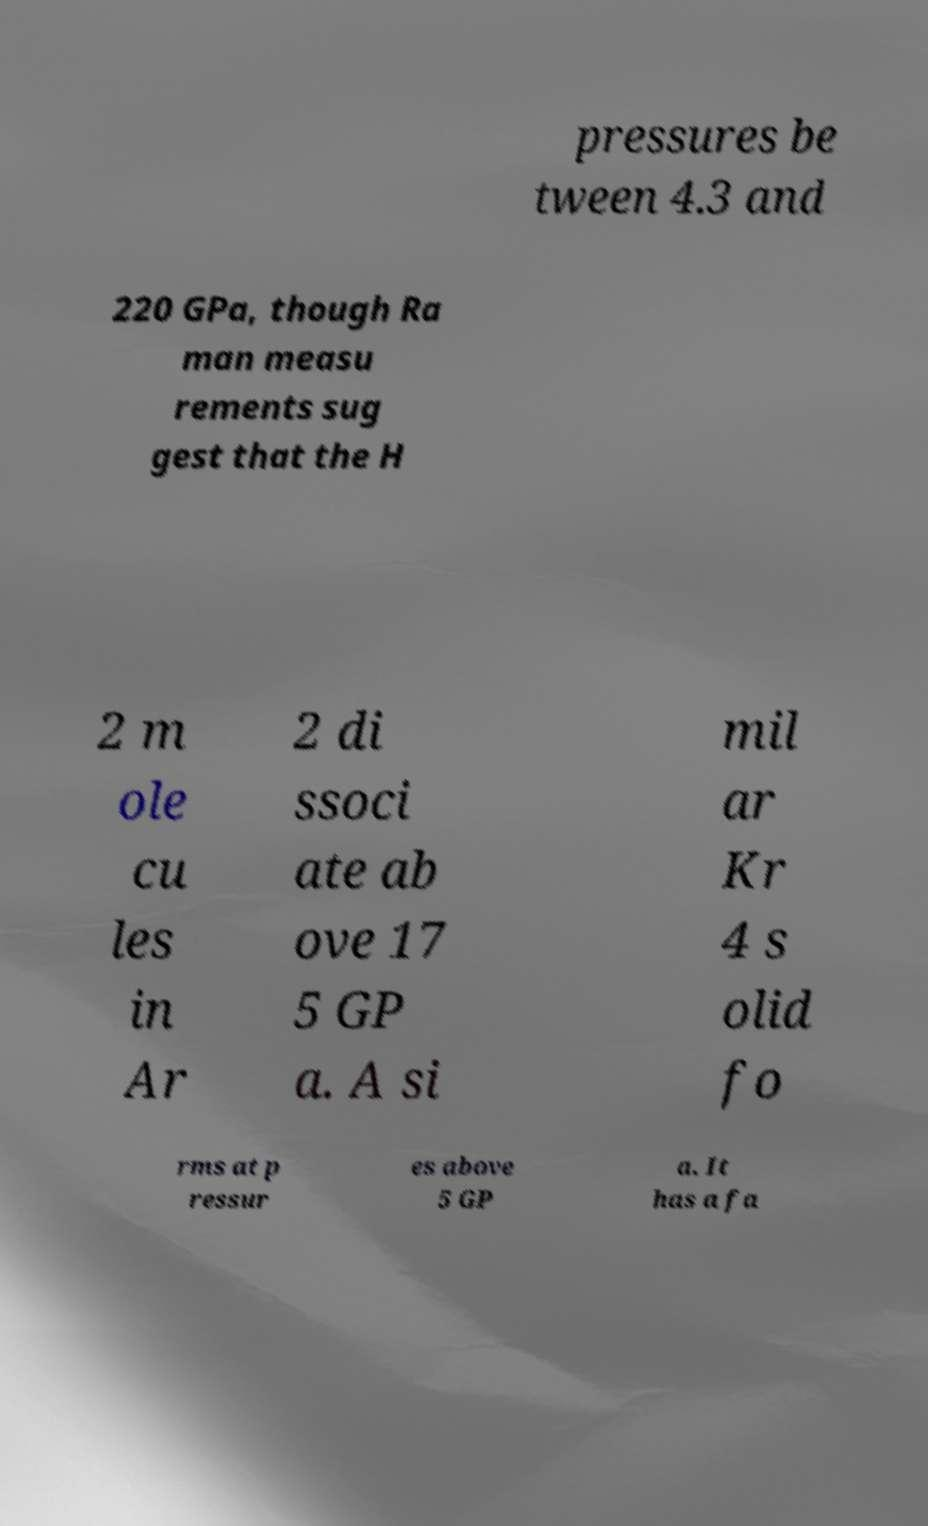Can you read and provide the text displayed in the image?This photo seems to have some interesting text. Can you extract and type it out for me? pressures be tween 4.3 and 220 GPa, though Ra man measu rements sug gest that the H 2 m ole cu les in Ar 2 di ssoci ate ab ove 17 5 GP a. A si mil ar Kr 4 s olid fo rms at p ressur es above 5 GP a. It has a fa 